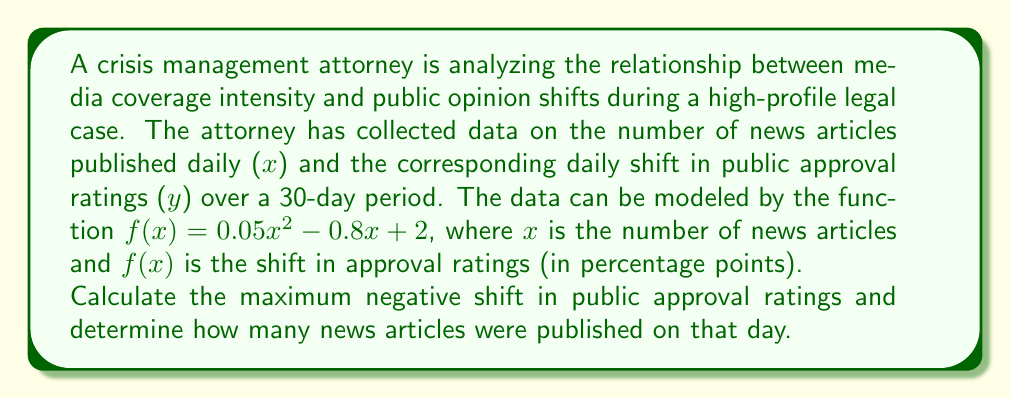Teach me how to tackle this problem. To solve this problem, we need to find the minimum point of the quadratic function, as this represents the maximum negative shift in approval ratings.

Step 1: Identify the quadratic function
$f(x) = 0.05x^2 - 0.8x + 2$

Step 2: Find the vertex of the parabola
For a quadratic function in the form $f(x) = ax^2 + bx + c$, the x-coordinate of the vertex is given by $x = -\frac{b}{2a}$

$a = 0.05$, $b = -0.8$

$x = -\frac{-0.8}{2(0.05)} = \frac{0.8}{0.1} = 8$

Step 3: Calculate the y-coordinate of the vertex
$f(8) = 0.05(8)^2 - 0.8(8) + 2$
$= 0.05(64) - 6.4 + 2$
$= 3.2 - 6.4 + 2$
$= -1.2$

Step 4: Interpret the results
The vertex (8, -1.2) represents the point where the function reaches its minimum value. This means:
- The maximum negative shift in public approval ratings is 1.2 percentage points.
- This occurred when 8 news articles were published in a day.
Answer: Maximum negative shift: 1.2 percentage points; Number of articles: 8 